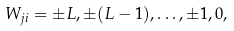Convert formula to latex. <formula><loc_0><loc_0><loc_500><loc_500>W _ { j i } = \pm L , \pm ( L - 1 ) , \dots , \pm 1 , 0 ,</formula> 